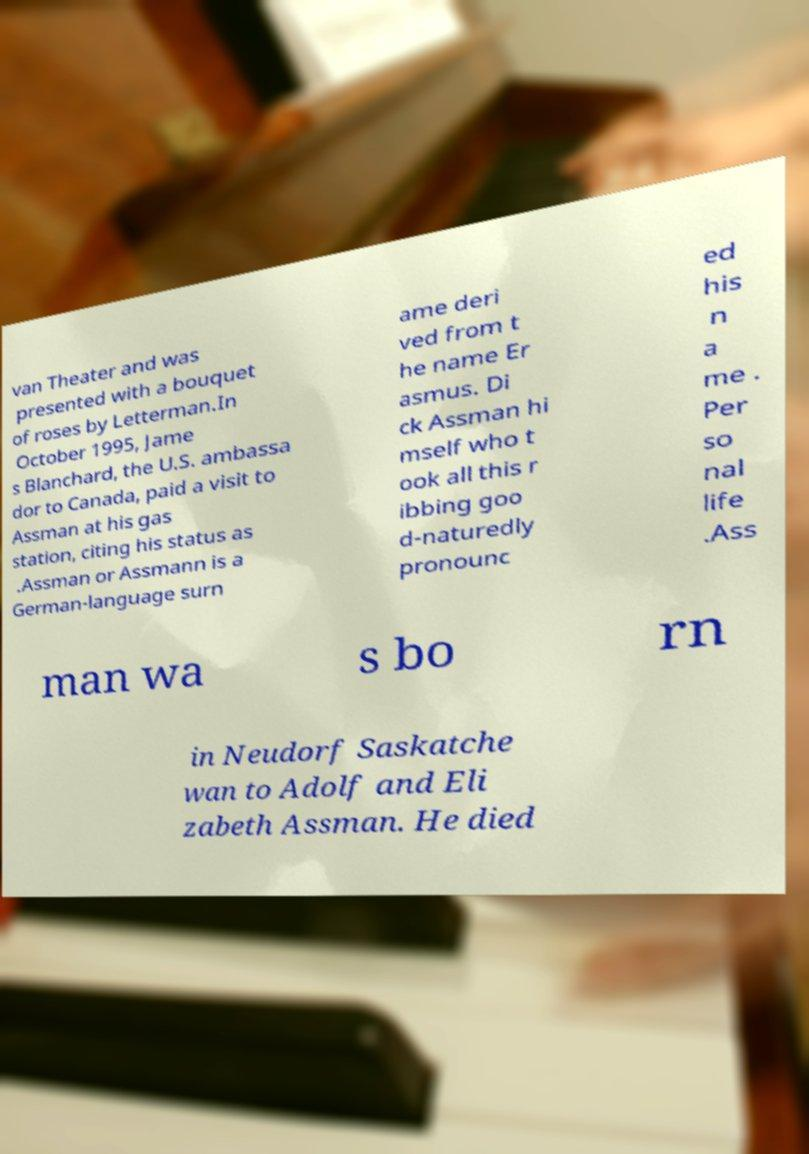For documentation purposes, I need the text within this image transcribed. Could you provide that? van Theater and was presented with a bouquet of roses by Letterman.In October 1995, Jame s Blanchard, the U.S. ambassa dor to Canada, paid a visit to Assman at his gas station, citing his status as .Assman or Assmann is a German-language surn ame deri ved from t he name Er asmus. Di ck Assman hi mself who t ook all this r ibbing goo d-naturedly pronounc ed his n a me . Per so nal life .Ass man wa s bo rn in Neudorf Saskatche wan to Adolf and Eli zabeth Assman. He died 